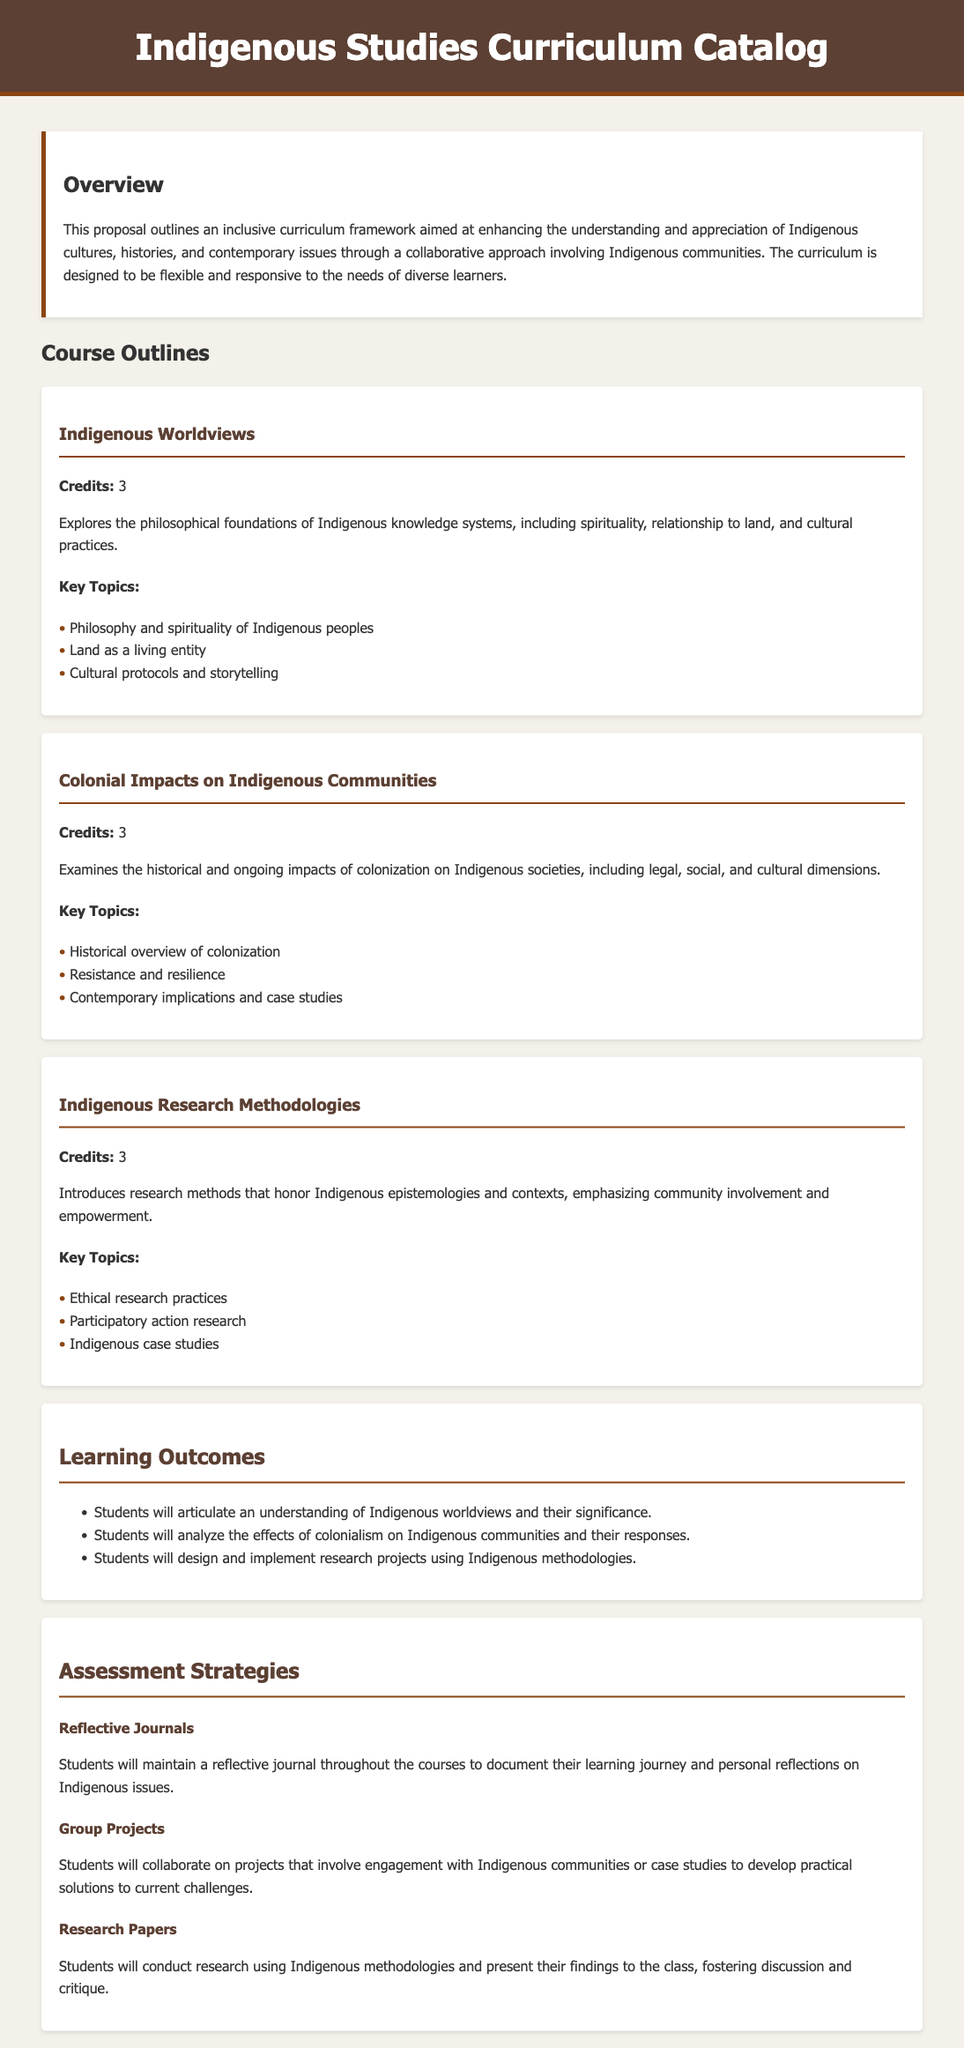What is the title of the document? The title is prominently displayed in the header of the document.
Answer: Indigenous Studies Curriculum Catalog How many credits is the course 'Indigenous Worldviews'? The document specifies the credits associated with the course in the course outline.
Answer: 3 What is the focus of the course 'Colonial Impacts on Indigenous Communities'? The focus is detailed in the course description.
Answer: Historical and ongoing impacts of colonization List one key topic from the course 'Indigenous Research Methodologies'. The document lists key topics under each course description.
Answer: Ethical research practices What is one assessment strategy mentioned in the catalog? The document outlines different assessment strategies alongside their descriptions.
Answer: Reflective Journals How many learning outcomes are specified in the curriculum? The number of learning outcomes is indicated in the learning outcomes section of the document.
Answer: Three What is the purpose of the curriculum framework? The purpose is described in the overview section of the document.
Answer: Enhancing the understanding and appreciation of Indigenous cultures Which course emphasizes community involvement in research? This is determined by looking at the course descriptions.
Answer: Indigenous Research Methodologies 